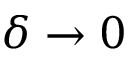Convert formula to latex. <formula><loc_0><loc_0><loc_500><loc_500>\delta \rightarrow 0</formula> 